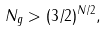Convert formula to latex. <formula><loc_0><loc_0><loc_500><loc_500>N _ { g } > ( 3 / 2 ) ^ { N / 2 } ,</formula> 